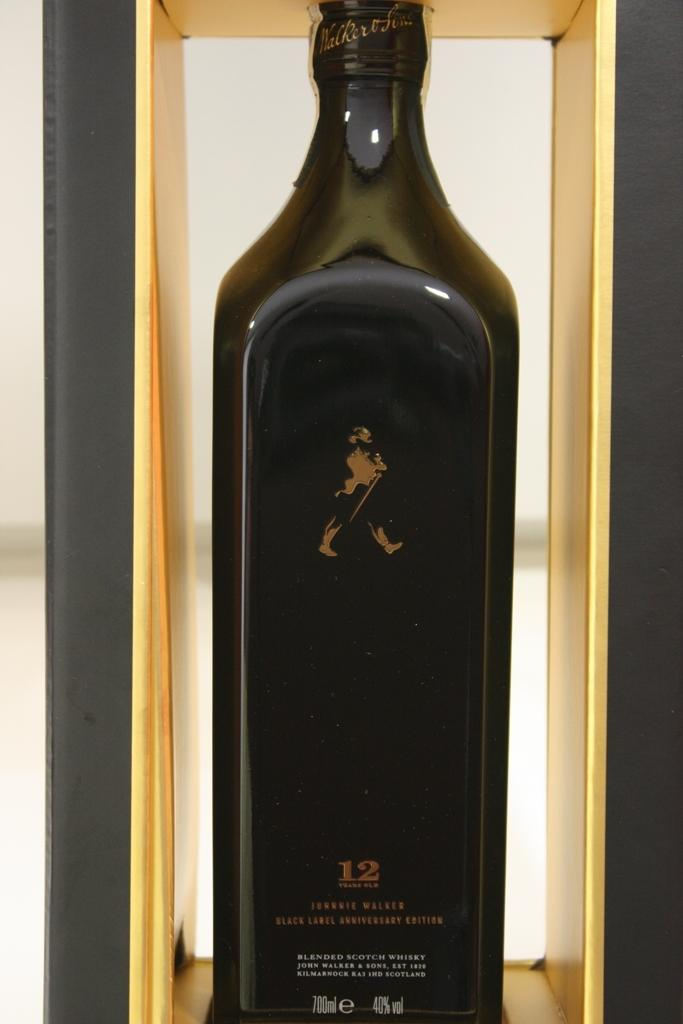What is the main object in the image? There is an alcohol bottle in the image. Can you describe the color of the alcohol bottle? The alcohol bottle is black in color. Is there a kitten swinging on the alcohol bottle in the image? No, there is no kitten or swing present in the image. 